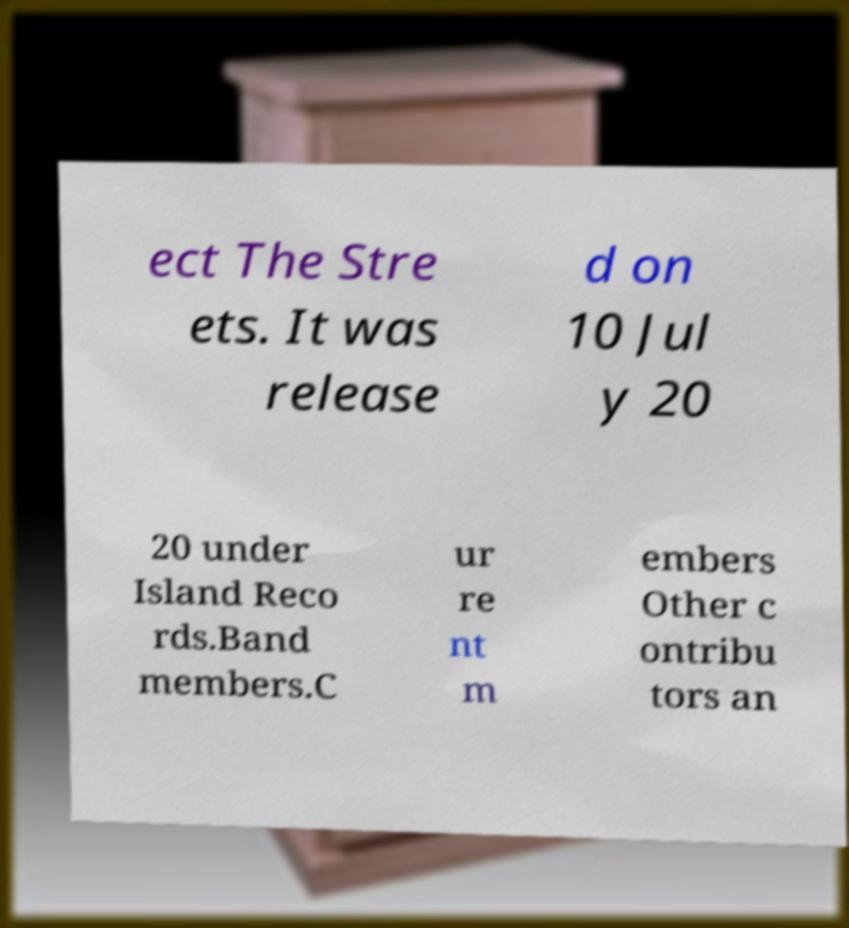For documentation purposes, I need the text within this image transcribed. Could you provide that? ect The Stre ets. It was release d on 10 Jul y 20 20 under Island Reco rds.Band members.C ur re nt m embers Other c ontribu tors an 